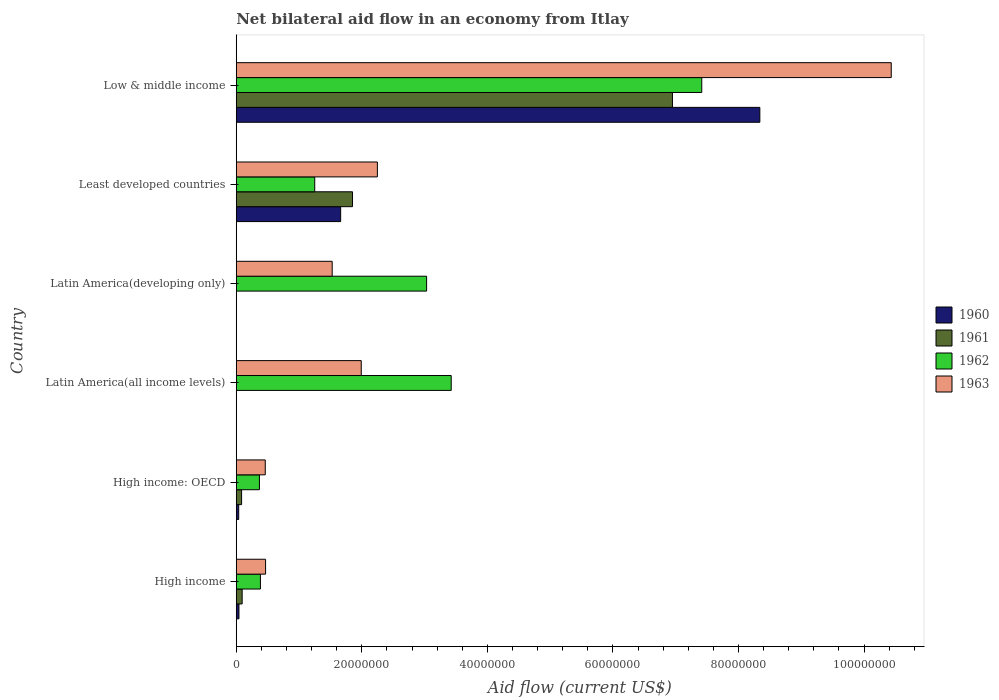How many different coloured bars are there?
Offer a very short reply. 4. How many groups of bars are there?
Provide a succinct answer. 6. Are the number of bars on each tick of the Y-axis equal?
Your answer should be very brief. No. How many bars are there on the 5th tick from the top?
Your response must be concise. 4. How many bars are there on the 3rd tick from the bottom?
Your response must be concise. 2. What is the label of the 1st group of bars from the top?
Your answer should be compact. Low & middle income. What is the net bilateral aid flow in 1963 in High income: OECD?
Your answer should be very brief. 4.62e+06. Across all countries, what is the maximum net bilateral aid flow in 1961?
Provide a short and direct response. 6.95e+07. Across all countries, what is the minimum net bilateral aid flow in 1960?
Provide a succinct answer. 0. In which country was the net bilateral aid flow in 1962 maximum?
Your response must be concise. Low & middle income. What is the total net bilateral aid flow in 1961 in the graph?
Make the answer very short. 8.98e+07. What is the difference between the net bilateral aid flow in 1962 in Latin America(developing only) and that in Least developed countries?
Make the answer very short. 1.78e+07. What is the difference between the net bilateral aid flow in 1961 in Least developed countries and the net bilateral aid flow in 1962 in High income: OECD?
Give a very brief answer. 1.48e+07. What is the average net bilateral aid flow in 1960 per country?
Your answer should be very brief. 1.68e+07. What is the difference between the net bilateral aid flow in 1962 and net bilateral aid flow in 1963 in Low & middle income?
Give a very brief answer. -3.02e+07. What is the ratio of the net bilateral aid flow in 1963 in Least developed countries to that in Low & middle income?
Make the answer very short. 0.22. Is the net bilateral aid flow in 1963 in Latin America(all income levels) less than that in Latin America(developing only)?
Your answer should be very brief. No. Is the difference between the net bilateral aid flow in 1962 in High income and Latin America(all income levels) greater than the difference between the net bilateral aid flow in 1963 in High income and Latin America(all income levels)?
Offer a terse response. No. What is the difference between the highest and the second highest net bilateral aid flow in 1960?
Ensure brevity in your answer.  6.68e+07. What is the difference between the highest and the lowest net bilateral aid flow in 1960?
Make the answer very short. 8.34e+07. In how many countries, is the net bilateral aid flow in 1960 greater than the average net bilateral aid flow in 1960 taken over all countries?
Your response must be concise. 1. Is the sum of the net bilateral aid flow in 1963 in High income and Low & middle income greater than the maximum net bilateral aid flow in 1961 across all countries?
Your response must be concise. Yes. How many countries are there in the graph?
Keep it short and to the point. 6. What is the difference between two consecutive major ticks on the X-axis?
Make the answer very short. 2.00e+07. Are the values on the major ticks of X-axis written in scientific E-notation?
Make the answer very short. No. Does the graph contain grids?
Your response must be concise. No. How are the legend labels stacked?
Give a very brief answer. Vertical. What is the title of the graph?
Give a very brief answer. Net bilateral aid flow in an economy from Itlay. What is the label or title of the X-axis?
Offer a terse response. Aid flow (current US$). What is the label or title of the Y-axis?
Offer a very short reply. Country. What is the Aid flow (current US$) of 1960 in High income?
Provide a short and direct response. 4.30e+05. What is the Aid flow (current US$) of 1961 in High income?
Provide a short and direct response. 9.40e+05. What is the Aid flow (current US$) in 1962 in High income?
Your answer should be very brief. 3.85e+06. What is the Aid flow (current US$) in 1963 in High income?
Provide a succinct answer. 4.67e+06. What is the Aid flow (current US$) of 1961 in High income: OECD?
Give a very brief answer. 8.50e+05. What is the Aid flow (current US$) in 1962 in High income: OECD?
Offer a very short reply. 3.69e+06. What is the Aid flow (current US$) in 1963 in High income: OECD?
Your response must be concise. 4.62e+06. What is the Aid flow (current US$) in 1960 in Latin America(all income levels)?
Your response must be concise. 0. What is the Aid flow (current US$) in 1961 in Latin America(all income levels)?
Your answer should be very brief. 0. What is the Aid flow (current US$) of 1962 in Latin America(all income levels)?
Keep it short and to the point. 3.42e+07. What is the Aid flow (current US$) of 1963 in Latin America(all income levels)?
Offer a very short reply. 1.99e+07. What is the Aid flow (current US$) in 1960 in Latin America(developing only)?
Provide a short and direct response. 0. What is the Aid flow (current US$) in 1961 in Latin America(developing only)?
Make the answer very short. 0. What is the Aid flow (current US$) of 1962 in Latin America(developing only)?
Your answer should be very brief. 3.03e+07. What is the Aid flow (current US$) of 1963 in Latin America(developing only)?
Offer a very short reply. 1.53e+07. What is the Aid flow (current US$) in 1960 in Least developed countries?
Provide a short and direct response. 1.66e+07. What is the Aid flow (current US$) in 1961 in Least developed countries?
Provide a succinct answer. 1.85e+07. What is the Aid flow (current US$) in 1962 in Least developed countries?
Offer a very short reply. 1.25e+07. What is the Aid flow (current US$) of 1963 in Least developed countries?
Ensure brevity in your answer.  2.25e+07. What is the Aid flow (current US$) in 1960 in Low & middle income?
Provide a short and direct response. 8.34e+07. What is the Aid flow (current US$) of 1961 in Low & middle income?
Keep it short and to the point. 6.95e+07. What is the Aid flow (current US$) in 1962 in Low & middle income?
Keep it short and to the point. 7.42e+07. What is the Aid flow (current US$) in 1963 in Low & middle income?
Offer a very short reply. 1.04e+08. Across all countries, what is the maximum Aid flow (current US$) of 1960?
Your response must be concise. 8.34e+07. Across all countries, what is the maximum Aid flow (current US$) of 1961?
Keep it short and to the point. 6.95e+07. Across all countries, what is the maximum Aid flow (current US$) in 1962?
Make the answer very short. 7.42e+07. Across all countries, what is the maximum Aid flow (current US$) in 1963?
Provide a succinct answer. 1.04e+08. Across all countries, what is the minimum Aid flow (current US$) in 1960?
Provide a succinct answer. 0. Across all countries, what is the minimum Aid flow (current US$) in 1961?
Your answer should be compact. 0. Across all countries, what is the minimum Aid flow (current US$) of 1962?
Provide a short and direct response. 3.69e+06. Across all countries, what is the minimum Aid flow (current US$) of 1963?
Give a very brief answer. 4.62e+06. What is the total Aid flow (current US$) in 1960 in the graph?
Provide a succinct answer. 1.01e+08. What is the total Aid flow (current US$) of 1961 in the graph?
Ensure brevity in your answer.  8.98e+07. What is the total Aid flow (current US$) of 1962 in the graph?
Your answer should be compact. 1.59e+08. What is the total Aid flow (current US$) in 1963 in the graph?
Your answer should be very brief. 1.71e+08. What is the difference between the Aid flow (current US$) in 1962 in High income and that in Latin America(all income levels)?
Provide a succinct answer. -3.04e+07. What is the difference between the Aid flow (current US$) of 1963 in High income and that in Latin America(all income levels)?
Give a very brief answer. -1.52e+07. What is the difference between the Aid flow (current US$) of 1962 in High income and that in Latin America(developing only)?
Keep it short and to the point. -2.65e+07. What is the difference between the Aid flow (current US$) in 1963 in High income and that in Latin America(developing only)?
Provide a succinct answer. -1.06e+07. What is the difference between the Aid flow (current US$) in 1960 in High income and that in Least developed countries?
Keep it short and to the point. -1.62e+07. What is the difference between the Aid flow (current US$) of 1961 in High income and that in Least developed countries?
Offer a very short reply. -1.76e+07. What is the difference between the Aid flow (current US$) in 1962 in High income and that in Least developed countries?
Provide a succinct answer. -8.65e+06. What is the difference between the Aid flow (current US$) in 1963 in High income and that in Least developed countries?
Your answer should be very brief. -1.78e+07. What is the difference between the Aid flow (current US$) of 1960 in High income and that in Low & middle income?
Your response must be concise. -8.30e+07. What is the difference between the Aid flow (current US$) in 1961 in High income and that in Low & middle income?
Give a very brief answer. -6.85e+07. What is the difference between the Aid flow (current US$) in 1962 in High income and that in Low & middle income?
Your answer should be very brief. -7.03e+07. What is the difference between the Aid flow (current US$) of 1963 in High income and that in Low & middle income?
Offer a very short reply. -9.97e+07. What is the difference between the Aid flow (current US$) in 1962 in High income: OECD and that in Latin America(all income levels)?
Make the answer very short. -3.06e+07. What is the difference between the Aid flow (current US$) in 1963 in High income: OECD and that in Latin America(all income levels)?
Make the answer very short. -1.53e+07. What is the difference between the Aid flow (current US$) in 1962 in High income: OECD and that in Latin America(developing only)?
Give a very brief answer. -2.66e+07. What is the difference between the Aid flow (current US$) of 1963 in High income: OECD and that in Latin America(developing only)?
Your answer should be compact. -1.07e+07. What is the difference between the Aid flow (current US$) in 1960 in High income: OECD and that in Least developed countries?
Your response must be concise. -1.62e+07. What is the difference between the Aid flow (current US$) in 1961 in High income: OECD and that in Least developed countries?
Make the answer very short. -1.77e+07. What is the difference between the Aid flow (current US$) of 1962 in High income: OECD and that in Least developed countries?
Give a very brief answer. -8.81e+06. What is the difference between the Aid flow (current US$) in 1963 in High income: OECD and that in Least developed countries?
Your answer should be very brief. -1.79e+07. What is the difference between the Aid flow (current US$) of 1960 in High income: OECD and that in Low & middle income?
Your answer should be very brief. -8.30e+07. What is the difference between the Aid flow (current US$) in 1961 in High income: OECD and that in Low & middle income?
Your answer should be compact. -6.86e+07. What is the difference between the Aid flow (current US$) in 1962 in High income: OECD and that in Low & middle income?
Provide a short and direct response. -7.05e+07. What is the difference between the Aid flow (current US$) in 1963 in High income: OECD and that in Low & middle income?
Your response must be concise. -9.97e+07. What is the difference between the Aid flow (current US$) in 1962 in Latin America(all income levels) and that in Latin America(developing only)?
Keep it short and to the point. 3.92e+06. What is the difference between the Aid flow (current US$) of 1963 in Latin America(all income levels) and that in Latin America(developing only)?
Offer a terse response. 4.63e+06. What is the difference between the Aid flow (current US$) in 1962 in Latin America(all income levels) and that in Least developed countries?
Your response must be concise. 2.17e+07. What is the difference between the Aid flow (current US$) of 1963 in Latin America(all income levels) and that in Least developed countries?
Your response must be concise. -2.57e+06. What is the difference between the Aid flow (current US$) in 1962 in Latin America(all income levels) and that in Low & middle income?
Give a very brief answer. -3.99e+07. What is the difference between the Aid flow (current US$) in 1963 in Latin America(all income levels) and that in Low & middle income?
Ensure brevity in your answer.  -8.44e+07. What is the difference between the Aid flow (current US$) of 1962 in Latin America(developing only) and that in Least developed countries?
Your answer should be compact. 1.78e+07. What is the difference between the Aid flow (current US$) of 1963 in Latin America(developing only) and that in Least developed countries?
Provide a succinct answer. -7.20e+06. What is the difference between the Aid flow (current US$) in 1962 in Latin America(developing only) and that in Low & middle income?
Make the answer very short. -4.38e+07. What is the difference between the Aid flow (current US$) of 1963 in Latin America(developing only) and that in Low & middle income?
Keep it short and to the point. -8.90e+07. What is the difference between the Aid flow (current US$) in 1960 in Least developed countries and that in Low & middle income?
Provide a short and direct response. -6.68e+07. What is the difference between the Aid flow (current US$) in 1961 in Least developed countries and that in Low & middle income?
Keep it short and to the point. -5.10e+07. What is the difference between the Aid flow (current US$) in 1962 in Least developed countries and that in Low & middle income?
Provide a succinct answer. -6.16e+07. What is the difference between the Aid flow (current US$) in 1963 in Least developed countries and that in Low & middle income?
Provide a short and direct response. -8.18e+07. What is the difference between the Aid flow (current US$) in 1960 in High income and the Aid flow (current US$) in 1961 in High income: OECD?
Your answer should be compact. -4.20e+05. What is the difference between the Aid flow (current US$) in 1960 in High income and the Aid flow (current US$) in 1962 in High income: OECD?
Your response must be concise. -3.26e+06. What is the difference between the Aid flow (current US$) of 1960 in High income and the Aid flow (current US$) of 1963 in High income: OECD?
Your answer should be very brief. -4.19e+06. What is the difference between the Aid flow (current US$) in 1961 in High income and the Aid flow (current US$) in 1962 in High income: OECD?
Provide a short and direct response. -2.75e+06. What is the difference between the Aid flow (current US$) in 1961 in High income and the Aid flow (current US$) in 1963 in High income: OECD?
Your answer should be very brief. -3.68e+06. What is the difference between the Aid flow (current US$) of 1962 in High income and the Aid flow (current US$) of 1963 in High income: OECD?
Keep it short and to the point. -7.70e+05. What is the difference between the Aid flow (current US$) in 1960 in High income and the Aid flow (current US$) in 1962 in Latin America(all income levels)?
Provide a succinct answer. -3.38e+07. What is the difference between the Aid flow (current US$) in 1960 in High income and the Aid flow (current US$) in 1963 in Latin America(all income levels)?
Ensure brevity in your answer.  -1.95e+07. What is the difference between the Aid flow (current US$) of 1961 in High income and the Aid flow (current US$) of 1962 in Latin America(all income levels)?
Provide a succinct answer. -3.33e+07. What is the difference between the Aid flow (current US$) of 1961 in High income and the Aid flow (current US$) of 1963 in Latin America(all income levels)?
Your response must be concise. -1.90e+07. What is the difference between the Aid flow (current US$) of 1962 in High income and the Aid flow (current US$) of 1963 in Latin America(all income levels)?
Your answer should be very brief. -1.61e+07. What is the difference between the Aid flow (current US$) of 1960 in High income and the Aid flow (current US$) of 1962 in Latin America(developing only)?
Your answer should be compact. -2.99e+07. What is the difference between the Aid flow (current US$) of 1960 in High income and the Aid flow (current US$) of 1963 in Latin America(developing only)?
Provide a short and direct response. -1.48e+07. What is the difference between the Aid flow (current US$) of 1961 in High income and the Aid flow (current US$) of 1962 in Latin America(developing only)?
Ensure brevity in your answer.  -2.94e+07. What is the difference between the Aid flow (current US$) of 1961 in High income and the Aid flow (current US$) of 1963 in Latin America(developing only)?
Ensure brevity in your answer.  -1.43e+07. What is the difference between the Aid flow (current US$) of 1962 in High income and the Aid flow (current US$) of 1963 in Latin America(developing only)?
Offer a very short reply. -1.14e+07. What is the difference between the Aid flow (current US$) of 1960 in High income and the Aid flow (current US$) of 1961 in Least developed countries?
Give a very brief answer. -1.81e+07. What is the difference between the Aid flow (current US$) in 1960 in High income and the Aid flow (current US$) in 1962 in Least developed countries?
Your answer should be very brief. -1.21e+07. What is the difference between the Aid flow (current US$) of 1960 in High income and the Aid flow (current US$) of 1963 in Least developed countries?
Your answer should be compact. -2.20e+07. What is the difference between the Aid flow (current US$) in 1961 in High income and the Aid flow (current US$) in 1962 in Least developed countries?
Make the answer very short. -1.16e+07. What is the difference between the Aid flow (current US$) in 1961 in High income and the Aid flow (current US$) in 1963 in Least developed countries?
Make the answer very short. -2.15e+07. What is the difference between the Aid flow (current US$) of 1962 in High income and the Aid flow (current US$) of 1963 in Least developed countries?
Your answer should be compact. -1.86e+07. What is the difference between the Aid flow (current US$) of 1960 in High income and the Aid flow (current US$) of 1961 in Low & middle income?
Your answer should be very brief. -6.90e+07. What is the difference between the Aid flow (current US$) in 1960 in High income and the Aid flow (current US$) in 1962 in Low & middle income?
Keep it short and to the point. -7.37e+07. What is the difference between the Aid flow (current US$) in 1960 in High income and the Aid flow (current US$) in 1963 in Low & middle income?
Your answer should be compact. -1.04e+08. What is the difference between the Aid flow (current US$) in 1961 in High income and the Aid flow (current US$) in 1962 in Low & middle income?
Offer a very short reply. -7.32e+07. What is the difference between the Aid flow (current US$) of 1961 in High income and the Aid flow (current US$) of 1963 in Low & middle income?
Give a very brief answer. -1.03e+08. What is the difference between the Aid flow (current US$) of 1962 in High income and the Aid flow (current US$) of 1963 in Low & middle income?
Make the answer very short. -1.00e+08. What is the difference between the Aid flow (current US$) in 1960 in High income: OECD and the Aid flow (current US$) in 1962 in Latin America(all income levels)?
Offer a terse response. -3.38e+07. What is the difference between the Aid flow (current US$) in 1960 in High income: OECD and the Aid flow (current US$) in 1963 in Latin America(all income levels)?
Give a very brief answer. -1.95e+07. What is the difference between the Aid flow (current US$) in 1961 in High income: OECD and the Aid flow (current US$) in 1962 in Latin America(all income levels)?
Keep it short and to the point. -3.34e+07. What is the difference between the Aid flow (current US$) of 1961 in High income: OECD and the Aid flow (current US$) of 1963 in Latin America(all income levels)?
Make the answer very short. -1.91e+07. What is the difference between the Aid flow (current US$) in 1962 in High income: OECD and the Aid flow (current US$) in 1963 in Latin America(all income levels)?
Your answer should be compact. -1.62e+07. What is the difference between the Aid flow (current US$) of 1960 in High income: OECD and the Aid flow (current US$) of 1962 in Latin America(developing only)?
Keep it short and to the point. -2.99e+07. What is the difference between the Aid flow (current US$) of 1960 in High income: OECD and the Aid flow (current US$) of 1963 in Latin America(developing only)?
Your answer should be compact. -1.49e+07. What is the difference between the Aid flow (current US$) in 1961 in High income: OECD and the Aid flow (current US$) in 1962 in Latin America(developing only)?
Provide a short and direct response. -2.95e+07. What is the difference between the Aid flow (current US$) in 1961 in High income: OECD and the Aid flow (current US$) in 1963 in Latin America(developing only)?
Provide a short and direct response. -1.44e+07. What is the difference between the Aid flow (current US$) of 1962 in High income: OECD and the Aid flow (current US$) of 1963 in Latin America(developing only)?
Give a very brief answer. -1.16e+07. What is the difference between the Aid flow (current US$) of 1960 in High income: OECD and the Aid flow (current US$) of 1961 in Least developed countries?
Provide a succinct answer. -1.81e+07. What is the difference between the Aid flow (current US$) of 1960 in High income: OECD and the Aid flow (current US$) of 1962 in Least developed countries?
Provide a succinct answer. -1.21e+07. What is the difference between the Aid flow (current US$) in 1960 in High income: OECD and the Aid flow (current US$) in 1963 in Least developed countries?
Your answer should be compact. -2.21e+07. What is the difference between the Aid flow (current US$) of 1961 in High income: OECD and the Aid flow (current US$) of 1962 in Least developed countries?
Your response must be concise. -1.16e+07. What is the difference between the Aid flow (current US$) in 1961 in High income: OECD and the Aid flow (current US$) in 1963 in Least developed countries?
Provide a succinct answer. -2.16e+07. What is the difference between the Aid flow (current US$) of 1962 in High income: OECD and the Aid flow (current US$) of 1963 in Least developed countries?
Give a very brief answer. -1.88e+07. What is the difference between the Aid flow (current US$) of 1960 in High income: OECD and the Aid flow (current US$) of 1961 in Low & middle income?
Your answer should be very brief. -6.91e+07. What is the difference between the Aid flow (current US$) in 1960 in High income: OECD and the Aid flow (current US$) in 1962 in Low & middle income?
Your response must be concise. -7.38e+07. What is the difference between the Aid flow (current US$) in 1960 in High income: OECD and the Aid flow (current US$) in 1963 in Low & middle income?
Your answer should be compact. -1.04e+08. What is the difference between the Aid flow (current US$) of 1961 in High income: OECD and the Aid flow (current US$) of 1962 in Low & middle income?
Your answer should be compact. -7.33e+07. What is the difference between the Aid flow (current US$) in 1961 in High income: OECD and the Aid flow (current US$) in 1963 in Low & middle income?
Ensure brevity in your answer.  -1.03e+08. What is the difference between the Aid flow (current US$) of 1962 in High income: OECD and the Aid flow (current US$) of 1963 in Low & middle income?
Keep it short and to the point. -1.01e+08. What is the difference between the Aid flow (current US$) in 1962 in Latin America(all income levels) and the Aid flow (current US$) in 1963 in Latin America(developing only)?
Your answer should be compact. 1.90e+07. What is the difference between the Aid flow (current US$) in 1962 in Latin America(all income levels) and the Aid flow (current US$) in 1963 in Least developed countries?
Your answer should be compact. 1.18e+07. What is the difference between the Aid flow (current US$) in 1962 in Latin America(all income levels) and the Aid flow (current US$) in 1963 in Low & middle income?
Offer a terse response. -7.01e+07. What is the difference between the Aid flow (current US$) of 1962 in Latin America(developing only) and the Aid flow (current US$) of 1963 in Least developed countries?
Your answer should be very brief. 7.84e+06. What is the difference between the Aid flow (current US$) of 1962 in Latin America(developing only) and the Aid flow (current US$) of 1963 in Low & middle income?
Ensure brevity in your answer.  -7.40e+07. What is the difference between the Aid flow (current US$) in 1960 in Least developed countries and the Aid flow (current US$) in 1961 in Low & middle income?
Your response must be concise. -5.28e+07. What is the difference between the Aid flow (current US$) in 1960 in Least developed countries and the Aid flow (current US$) in 1962 in Low & middle income?
Give a very brief answer. -5.75e+07. What is the difference between the Aid flow (current US$) of 1960 in Least developed countries and the Aid flow (current US$) of 1963 in Low & middle income?
Give a very brief answer. -8.77e+07. What is the difference between the Aid flow (current US$) of 1961 in Least developed countries and the Aid flow (current US$) of 1962 in Low & middle income?
Offer a very short reply. -5.56e+07. What is the difference between the Aid flow (current US$) in 1961 in Least developed countries and the Aid flow (current US$) in 1963 in Low & middle income?
Your response must be concise. -8.58e+07. What is the difference between the Aid flow (current US$) in 1962 in Least developed countries and the Aid flow (current US$) in 1963 in Low & middle income?
Keep it short and to the point. -9.18e+07. What is the average Aid flow (current US$) in 1960 per country?
Keep it short and to the point. 1.68e+07. What is the average Aid flow (current US$) of 1961 per country?
Offer a terse response. 1.50e+07. What is the average Aid flow (current US$) in 1962 per country?
Ensure brevity in your answer.  2.65e+07. What is the average Aid flow (current US$) in 1963 per country?
Provide a succinct answer. 2.85e+07. What is the difference between the Aid flow (current US$) of 1960 and Aid flow (current US$) of 1961 in High income?
Give a very brief answer. -5.10e+05. What is the difference between the Aid flow (current US$) in 1960 and Aid flow (current US$) in 1962 in High income?
Make the answer very short. -3.42e+06. What is the difference between the Aid flow (current US$) of 1960 and Aid flow (current US$) of 1963 in High income?
Keep it short and to the point. -4.24e+06. What is the difference between the Aid flow (current US$) in 1961 and Aid flow (current US$) in 1962 in High income?
Make the answer very short. -2.91e+06. What is the difference between the Aid flow (current US$) in 1961 and Aid flow (current US$) in 1963 in High income?
Offer a terse response. -3.73e+06. What is the difference between the Aid flow (current US$) in 1962 and Aid flow (current US$) in 1963 in High income?
Offer a terse response. -8.20e+05. What is the difference between the Aid flow (current US$) of 1960 and Aid flow (current US$) of 1961 in High income: OECD?
Provide a short and direct response. -4.60e+05. What is the difference between the Aid flow (current US$) in 1960 and Aid flow (current US$) in 1962 in High income: OECD?
Keep it short and to the point. -3.30e+06. What is the difference between the Aid flow (current US$) of 1960 and Aid flow (current US$) of 1963 in High income: OECD?
Keep it short and to the point. -4.23e+06. What is the difference between the Aid flow (current US$) of 1961 and Aid flow (current US$) of 1962 in High income: OECD?
Keep it short and to the point. -2.84e+06. What is the difference between the Aid flow (current US$) in 1961 and Aid flow (current US$) in 1963 in High income: OECD?
Offer a terse response. -3.77e+06. What is the difference between the Aid flow (current US$) of 1962 and Aid flow (current US$) of 1963 in High income: OECD?
Offer a very short reply. -9.30e+05. What is the difference between the Aid flow (current US$) in 1962 and Aid flow (current US$) in 1963 in Latin America(all income levels)?
Offer a very short reply. 1.43e+07. What is the difference between the Aid flow (current US$) in 1962 and Aid flow (current US$) in 1963 in Latin America(developing only)?
Provide a short and direct response. 1.50e+07. What is the difference between the Aid flow (current US$) of 1960 and Aid flow (current US$) of 1961 in Least developed countries?
Provide a succinct answer. -1.89e+06. What is the difference between the Aid flow (current US$) of 1960 and Aid flow (current US$) of 1962 in Least developed countries?
Ensure brevity in your answer.  4.13e+06. What is the difference between the Aid flow (current US$) of 1960 and Aid flow (current US$) of 1963 in Least developed countries?
Your answer should be very brief. -5.85e+06. What is the difference between the Aid flow (current US$) in 1961 and Aid flow (current US$) in 1962 in Least developed countries?
Provide a short and direct response. 6.02e+06. What is the difference between the Aid flow (current US$) in 1961 and Aid flow (current US$) in 1963 in Least developed countries?
Offer a terse response. -3.96e+06. What is the difference between the Aid flow (current US$) of 1962 and Aid flow (current US$) of 1963 in Least developed countries?
Your response must be concise. -9.98e+06. What is the difference between the Aid flow (current US$) of 1960 and Aid flow (current US$) of 1961 in Low & middle income?
Your answer should be compact. 1.39e+07. What is the difference between the Aid flow (current US$) of 1960 and Aid flow (current US$) of 1962 in Low & middle income?
Make the answer very short. 9.25e+06. What is the difference between the Aid flow (current US$) in 1960 and Aid flow (current US$) in 1963 in Low & middle income?
Provide a short and direct response. -2.09e+07. What is the difference between the Aid flow (current US$) in 1961 and Aid flow (current US$) in 1962 in Low & middle income?
Your answer should be very brief. -4.67e+06. What is the difference between the Aid flow (current US$) of 1961 and Aid flow (current US$) of 1963 in Low & middle income?
Provide a succinct answer. -3.48e+07. What is the difference between the Aid flow (current US$) in 1962 and Aid flow (current US$) in 1963 in Low & middle income?
Keep it short and to the point. -3.02e+07. What is the ratio of the Aid flow (current US$) of 1960 in High income to that in High income: OECD?
Provide a short and direct response. 1.1. What is the ratio of the Aid flow (current US$) in 1961 in High income to that in High income: OECD?
Provide a short and direct response. 1.11. What is the ratio of the Aid flow (current US$) of 1962 in High income to that in High income: OECD?
Your answer should be very brief. 1.04. What is the ratio of the Aid flow (current US$) of 1963 in High income to that in High income: OECD?
Your response must be concise. 1.01. What is the ratio of the Aid flow (current US$) of 1962 in High income to that in Latin America(all income levels)?
Keep it short and to the point. 0.11. What is the ratio of the Aid flow (current US$) in 1963 in High income to that in Latin America(all income levels)?
Offer a terse response. 0.23. What is the ratio of the Aid flow (current US$) of 1962 in High income to that in Latin America(developing only)?
Your response must be concise. 0.13. What is the ratio of the Aid flow (current US$) of 1963 in High income to that in Latin America(developing only)?
Your response must be concise. 0.31. What is the ratio of the Aid flow (current US$) in 1960 in High income to that in Least developed countries?
Provide a short and direct response. 0.03. What is the ratio of the Aid flow (current US$) in 1961 in High income to that in Least developed countries?
Provide a short and direct response. 0.05. What is the ratio of the Aid flow (current US$) in 1962 in High income to that in Least developed countries?
Your answer should be very brief. 0.31. What is the ratio of the Aid flow (current US$) of 1963 in High income to that in Least developed countries?
Offer a terse response. 0.21. What is the ratio of the Aid flow (current US$) of 1960 in High income to that in Low & middle income?
Your answer should be very brief. 0.01. What is the ratio of the Aid flow (current US$) of 1961 in High income to that in Low & middle income?
Keep it short and to the point. 0.01. What is the ratio of the Aid flow (current US$) of 1962 in High income to that in Low & middle income?
Your answer should be very brief. 0.05. What is the ratio of the Aid flow (current US$) in 1963 in High income to that in Low & middle income?
Offer a very short reply. 0.04. What is the ratio of the Aid flow (current US$) in 1962 in High income: OECD to that in Latin America(all income levels)?
Provide a succinct answer. 0.11. What is the ratio of the Aid flow (current US$) in 1963 in High income: OECD to that in Latin America(all income levels)?
Offer a terse response. 0.23. What is the ratio of the Aid flow (current US$) of 1962 in High income: OECD to that in Latin America(developing only)?
Provide a succinct answer. 0.12. What is the ratio of the Aid flow (current US$) in 1963 in High income: OECD to that in Latin America(developing only)?
Offer a terse response. 0.3. What is the ratio of the Aid flow (current US$) in 1960 in High income: OECD to that in Least developed countries?
Provide a short and direct response. 0.02. What is the ratio of the Aid flow (current US$) of 1961 in High income: OECD to that in Least developed countries?
Ensure brevity in your answer.  0.05. What is the ratio of the Aid flow (current US$) in 1962 in High income: OECD to that in Least developed countries?
Your answer should be very brief. 0.3. What is the ratio of the Aid flow (current US$) of 1963 in High income: OECD to that in Least developed countries?
Make the answer very short. 0.21. What is the ratio of the Aid flow (current US$) in 1960 in High income: OECD to that in Low & middle income?
Provide a short and direct response. 0. What is the ratio of the Aid flow (current US$) in 1961 in High income: OECD to that in Low & middle income?
Make the answer very short. 0.01. What is the ratio of the Aid flow (current US$) in 1962 in High income: OECD to that in Low & middle income?
Keep it short and to the point. 0.05. What is the ratio of the Aid flow (current US$) in 1963 in High income: OECD to that in Low & middle income?
Offer a very short reply. 0.04. What is the ratio of the Aid flow (current US$) in 1962 in Latin America(all income levels) to that in Latin America(developing only)?
Your response must be concise. 1.13. What is the ratio of the Aid flow (current US$) of 1963 in Latin America(all income levels) to that in Latin America(developing only)?
Provide a succinct answer. 1.3. What is the ratio of the Aid flow (current US$) of 1962 in Latin America(all income levels) to that in Least developed countries?
Make the answer very short. 2.74. What is the ratio of the Aid flow (current US$) in 1963 in Latin America(all income levels) to that in Least developed countries?
Make the answer very short. 0.89. What is the ratio of the Aid flow (current US$) of 1962 in Latin America(all income levels) to that in Low & middle income?
Offer a very short reply. 0.46. What is the ratio of the Aid flow (current US$) of 1963 in Latin America(all income levels) to that in Low & middle income?
Offer a very short reply. 0.19. What is the ratio of the Aid flow (current US$) in 1962 in Latin America(developing only) to that in Least developed countries?
Offer a terse response. 2.43. What is the ratio of the Aid flow (current US$) of 1963 in Latin America(developing only) to that in Least developed countries?
Give a very brief answer. 0.68. What is the ratio of the Aid flow (current US$) in 1962 in Latin America(developing only) to that in Low & middle income?
Provide a short and direct response. 0.41. What is the ratio of the Aid flow (current US$) of 1963 in Latin America(developing only) to that in Low & middle income?
Ensure brevity in your answer.  0.15. What is the ratio of the Aid flow (current US$) in 1960 in Least developed countries to that in Low & middle income?
Keep it short and to the point. 0.2. What is the ratio of the Aid flow (current US$) in 1961 in Least developed countries to that in Low & middle income?
Ensure brevity in your answer.  0.27. What is the ratio of the Aid flow (current US$) in 1962 in Least developed countries to that in Low & middle income?
Provide a short and direct response. 0.17. What is the ratio of the Aid flow (current US$) in 1963 in Least developed countries to that in Low & middle income?
Your answer should be very brief. 0.22. What is the difference between the highest and the second highest Aid flow (current US$) of 1960?
Give a very brief answer. 6.68e+07. What is the difference between the highest and the second highest Aid flow (current US$) of 1961?
Make the answer very short. 5.10e+07. What is the difference between the highest and the second highest Aid flow (current US$) of 1962?
Ensure brevity in your answer.  3.99e+07. What is the difference between the highest and the second highest Aid flow (current US$) in 1963?
Provide a succinct answer. 8.18e+07. What is the difference between the highest and the lowest Aid flow (current US$) of 1960?
Ensure brevity in your answer.  8.34e+07. What is the difference between the highest and the lowest Aid flow (current US$) of 1961?
Make the answer very short. 6.95e+07. What is the difference between the highest and the lowest Aid flow (current US$) in 1962?
Give a very brief answer. 7.05e+07. What is the difference between the highest and the lowest Aid flow (current US$) in 1963?
Ensure brevity in your answer.  9.97e+07. 